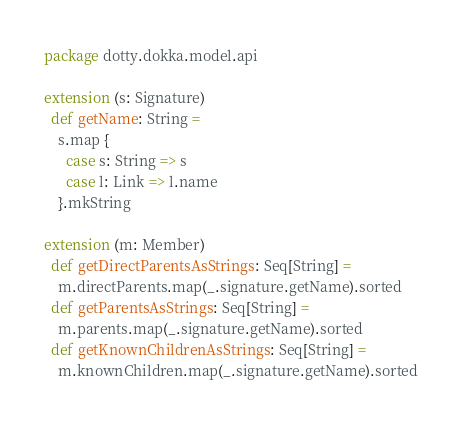Convert code to text. <code><loc_0><loc_0><loc_500><loc_500><_Scala_>package dotty.dokka.model.api

extension (s: Signature)
  def getName: String =
    s.map {
      case s: String => s
      case l: Link => l.name
    }.mkString

extension (m: Member)
  def getDirectParentsAsStrings: Seq[String] =
    m.directParents.map(_.signature.getName).sorted
  def getParentsAsStrings: Seq[String] =
    m.parents.map(_.signature.getName).sorted
  def getKnownChildrenAsStrings: Seq[String] =
    m.knownChildren.map(_.signature.getName).sorted
</code> 